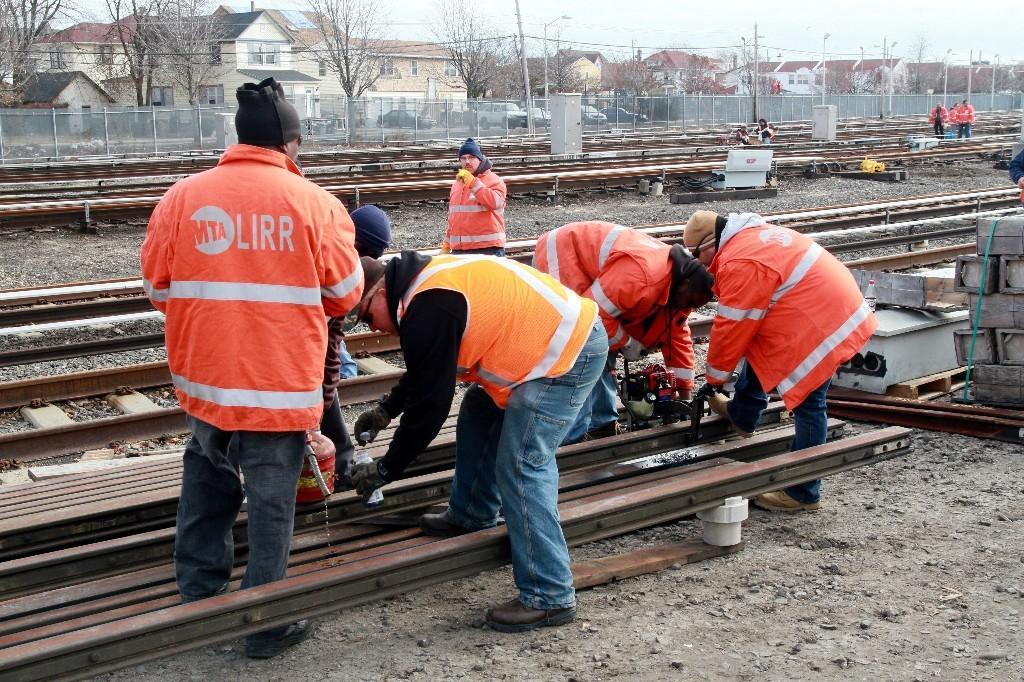In one or two sentences, can you explain what this image depicts? This picture is clicked outside. In the center we can see the group of persons standing, holding some objects and seems to be working and we can see the gravels, railway tracks, metal objects. In the background we can see the sky, houses, trees, cables, poles, mesh, metal rods, group of persons and many other objects. 